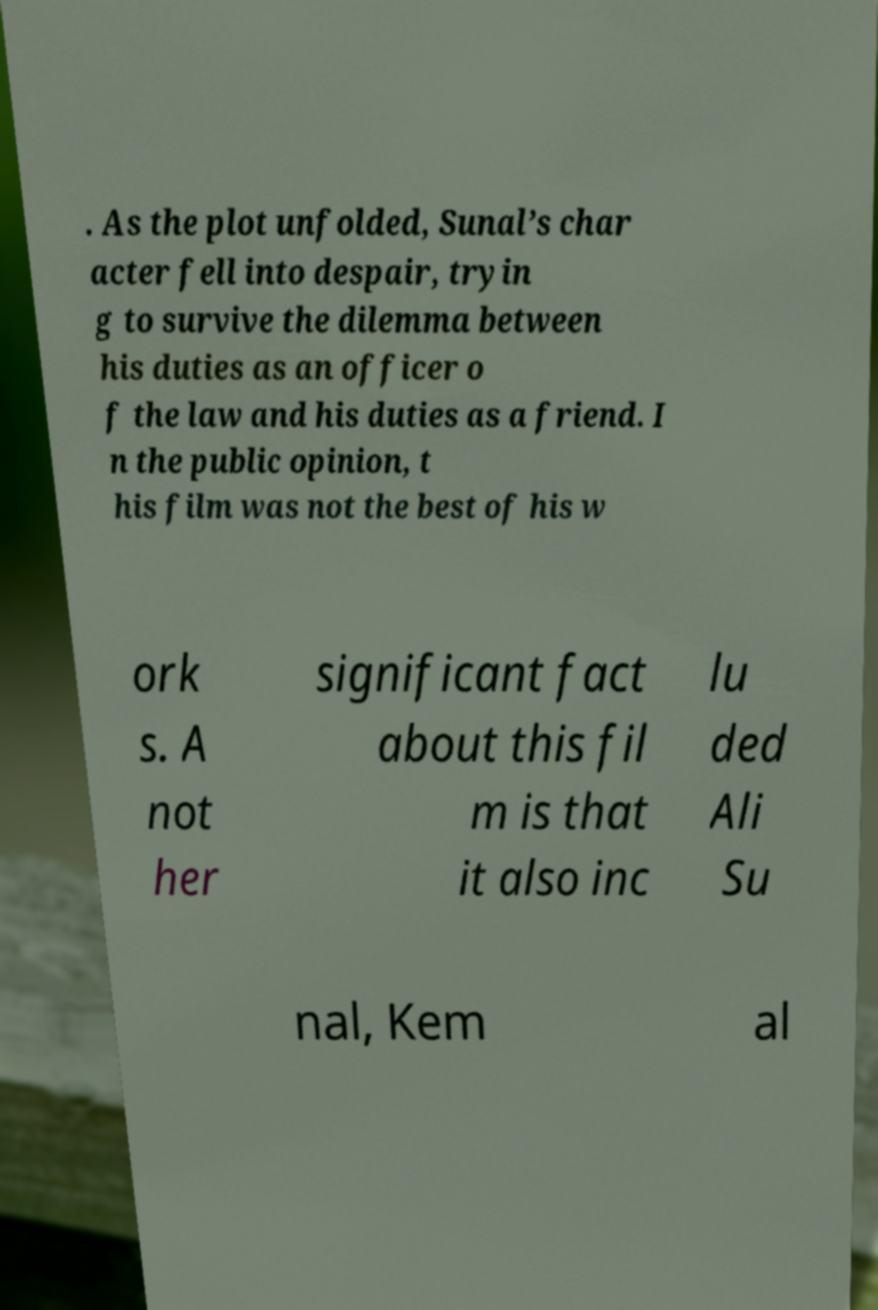Can you read and provide the text displayed in the image?This photo seems to have some interesting text. Can you extract and type it out for me? . As the plot unfolded, Sunal’s char acter fell into despair, tryin g to survive the dilemma between his duties as an officer o f the law and his duties as a friend. I n the public opinion, t his film was not the best of his w ork s. A not her significant fact about this fil m is that it also inc lu ded Ali Su nal, Kem al 